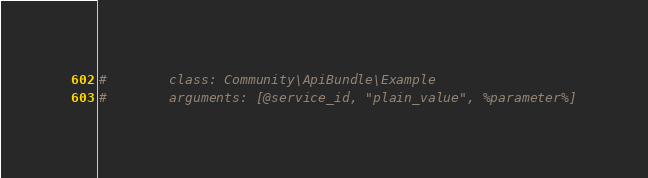Convert code to text. <code><loc_0><loc_0><loc_500><loc_500><_YAML_>#        class: Community\ApiBundle\Example
#        arguments: [@service_id, "plain_value", %parameter%]
</code> 